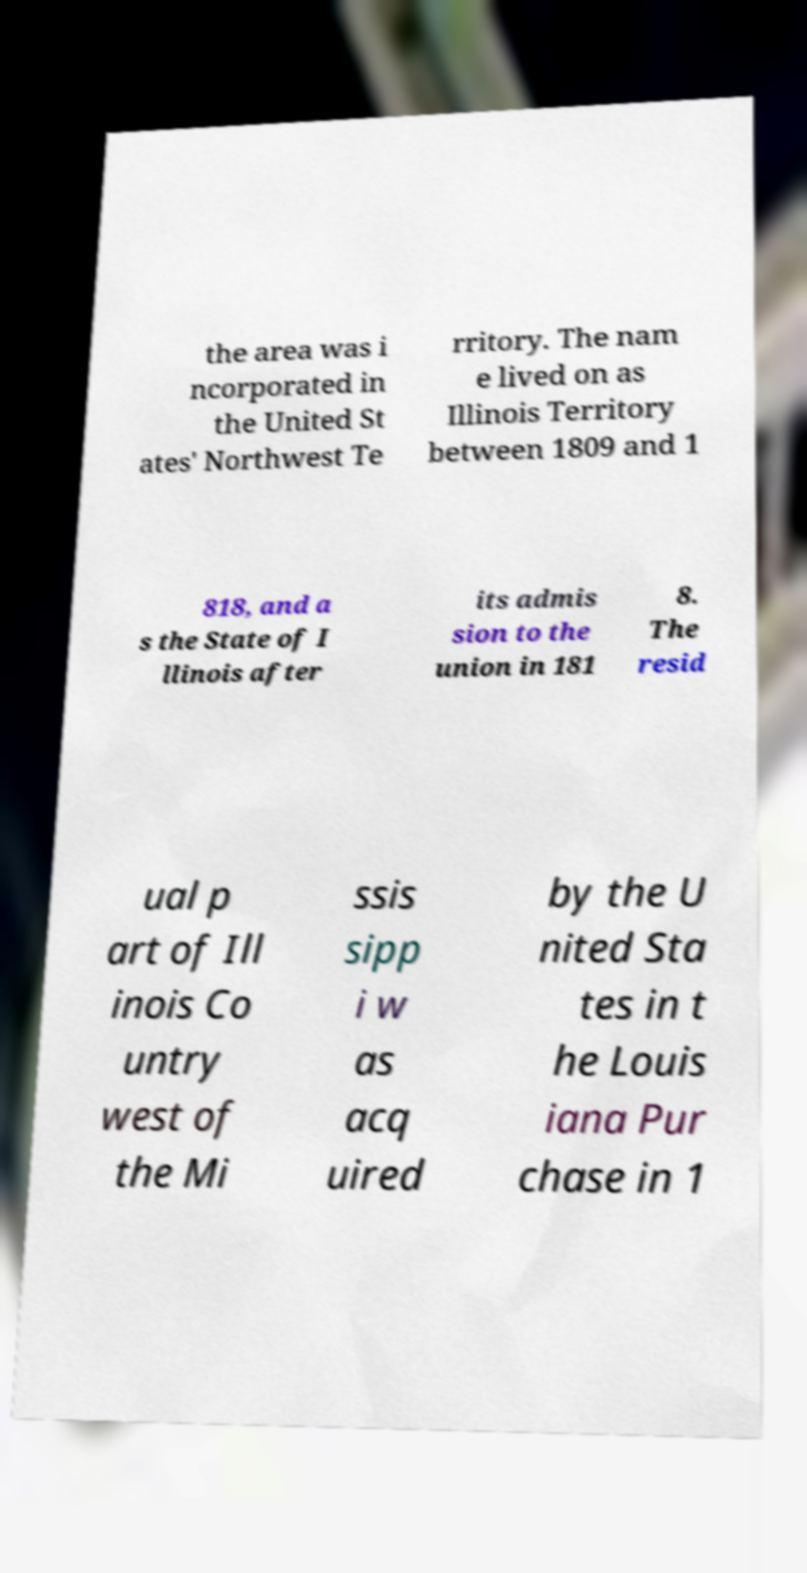Can you read and provide the text displayed in the image?This photo seems to have some interesting text. Can you extract and type it out for me? the area was i ncorporated in the United St ates' Northwest Te rritory. The nam e lived on as Illinois Territory between 1809 and 1 818, and a s the State of I llinois after its admis sion to the union in 181 8. The resid ual p art of Ill inois Co untry west of the Mi ssis sipp i w as acq uired by the U nited Sta tes in t he Louis iana Pur chase in 1 